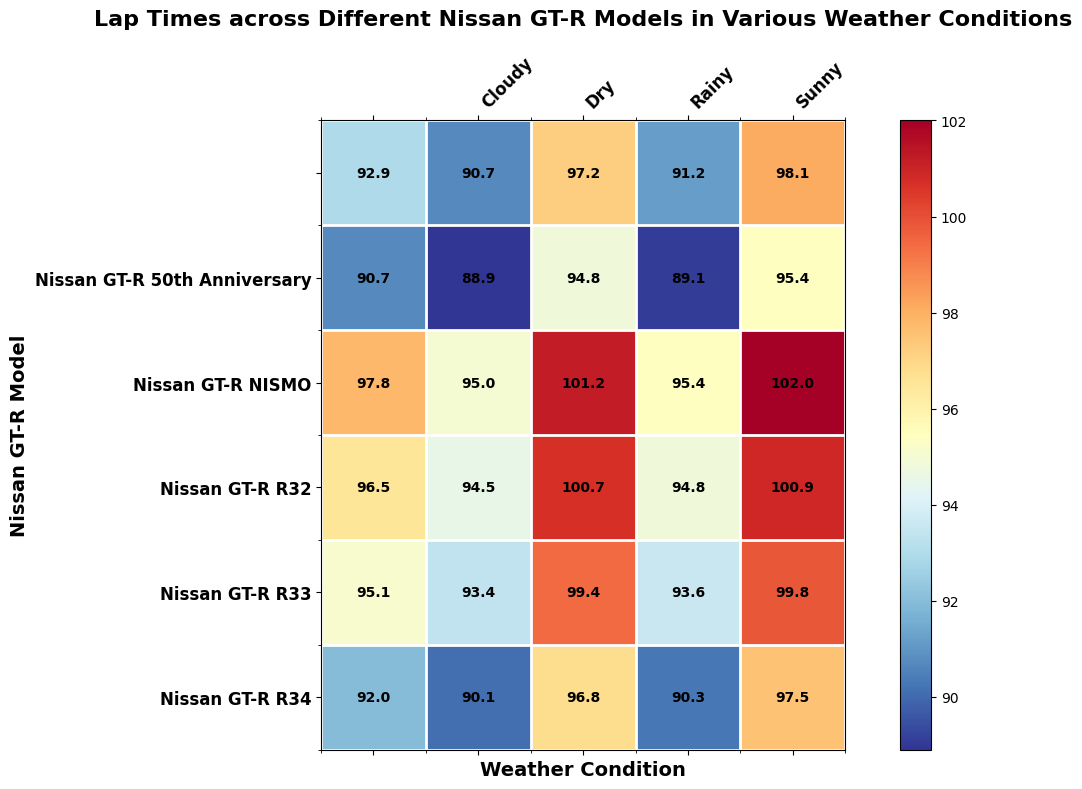What model has the fastest lap time in sunny conditions? The heatmap shows lap times for different Nissan GT-R models across various weather conditions. By checking the "Sunny" column, the Nissan GT-R NISMO has the fastest lap time of 89.1 seconds.
Answer: Nissan GT-R NISMO How much faster is the Nissan GT-R R35 in dry conditions compared to rainy conditions? Locate the lap times for the Nissan GT-R R35 in both dry and rainy conditions. For dry, it's 90.1 seconds, and for rainy, it's 96.8 seconds. The difference is 96.8 - 90.1 = 6.7 seconds.
Answer: 6.7 seconds Which condition generally yields the fastest lap times across all models? Scan each weather condition column to compare the general lap times. Notice that 'Dry' conditions have consistently lower lap times across most models, indicating it generally yields the fastest lap times.
Answer: Dry What's the average lap time for the Nissan GT-R R34 across all weather conditions? Sum the lap times for the Nissan GT-R R34 across all conditions (93.6 + 99.4 + 95.1 + 93.4 + 99.8) = 481.3 seconds. Divide by the number of conditions (5) to get the average: 481.3 / 5 = 96.26 seconds.
Answer: 96.26 seconds Is the lap time of Nissan GT-R 50th Anniversary faster in wet or cloudy conditions? Compare lap times for the Nissan GT-R 50th Anniversary in wet (98.1 seconds) and cloudy (92.9 seconds) conditions. The lap time is faster in cloudy conditions as 92.9 seconds is less than 98.1 seconds.
Answer: Cloudy How does the Nissan GT-R R32 perform in rainy conditions relative to sunny conditions? Check the lap times for the Nissan GT-R R32 in rainy and sunny conditions. For rainy, it's 101.2 seconds, and for sunny, it's 95.4 seconds. Rainy conditions are slower by 101.2 - 95.4 = 5.8 seconds.
Answer: Rainy conditions are slower by 5.8 seconds What's the difference in lap times between the fastest and slowest models in wet conditions? Identify the fastest (Nissan GT-R NISMO at 95.4 seconds) and the slowest (Nissan GT-R R32 at 102 seconds) lap times in wet conditions. The difference is 102 - 95.4 = 6.6 seconds.
Answer: 6.6 seconds Compare the lap times of the Nissan GT-R R33 and Nissan GT-R NISMO in sunny conditions. Who is faster and by how much? Look at the sunny lap times for the Nissan GT-R R33 (94.8 seconds) and Nissan GT-R NISMO (89.1 seconds). The NISMO is faster. The difference is 94.8 - 89.1 = 5.7 seconds.
Answer: NISMO is faster by 5.7 seconds What is the median lap time for the Nissan GT-R NISMO across all weather conditions? List the lap times for the Nissan GT-R NISMO (89.1, 94.8, 90.7, 88.9, 95.4) and find the median value. When ordered (88.9, 89.1, 90.7, 94.8, 95.4), the median (middle value) is 90.7 seconds.
Answer: 90.7 seconds 